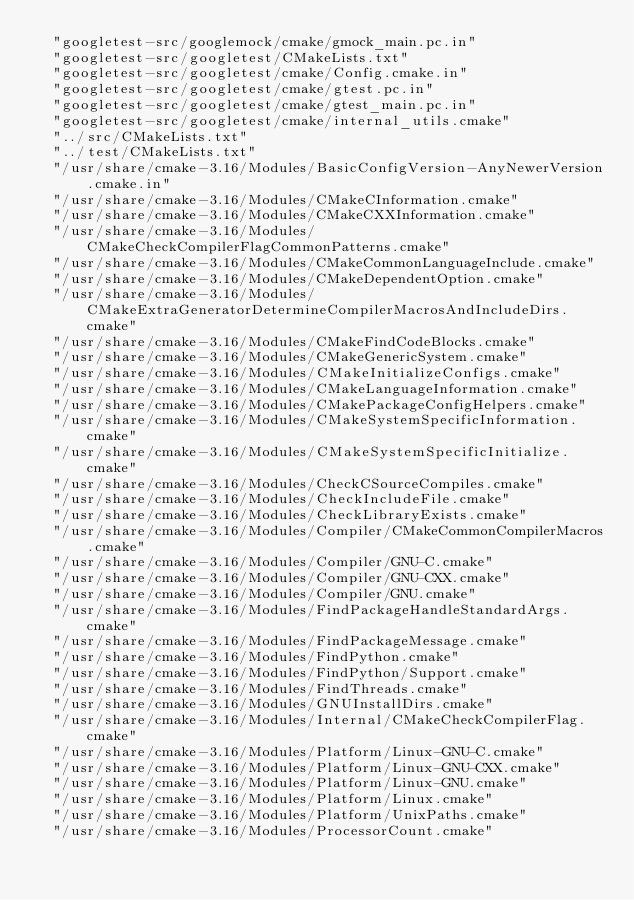Convert code to text. <code><loc_0><loc_0><loc_500><loc_500><_CMake_>  "googletest-src/googlemock/cmake/gmock_main.pc.in"
  "googletest-src/googletest/CMakeLists.txt"
  "googletest-src/googletest/cmake/Config.cmake.in"
  "googletest-src/googletest/cmake/gtest.pc.in"
  "googletest-src/googletest/cmake/gtest_main.pc.in"
  "googletest-src/googletest/cmake/internal_utils.cmake"
  "../src/CMakeLists.txt"
  "../test/CMakeLists.txt"
  "/usr/share/cmake-3.16/Modules/BasicConfigVersion-AnyNewerVersion.cmake.in"
  "/usr/share/cmake-3.16/Modules/CMakeCInformation.cmake"
  "/usr/share/cmake-3.16/Modules/CMakeCXXInformation.cmake"
  "/usr/share/cmake-3.16/Modules/CMakeCheckCompilerFlagCommonPatterns.cmake"
  "/usr/share/cmake-3.16/Modules/CMakeCommonLanguageInclude.cmake"
  "/usr/share/cmake-3.16/Modules/CMakeDependentOption.cmake"
  "/usr/share/cmake-3.16/Modules/CMakeExtraGeneratorDetermineCompilerMacrosAndIncludeDirs.cmake"
  "/usr/share/cmake-3.16/Modules/CMakeFindCodeBlocks.cmake"
  "/usr/share/cmake-3.16/Modules/CMakeGenericSystem.cmake"
  "/usr/share/cmake-3.16/Modules/CMakeInitializeConfigs.cmake"
  "/usr/share/cmake-3.16/Modules/CMakeLanguageInformation.cmake"
  "/usr/share/cmake-3.16/Modules/CMakePackageConfigHelpers.cmake"
  "/usr/share/cmake-3.16/Modules/CMakeSystemSpecificInformation.cmake"
  "/usr/share/cmake-3.16/Modules/CMakeSystemSpecificInitialize.cmake"
  "/usr/share/cmake-3.16/Modules/CheckCSourceCompiles.cmake"
  "/usr/share/cmake-3.16/Modules/CheckIncludeFile.cmake"
  "/usr/share/cmake-3.16/Modules/CheckLibraryExists.cmake"
  "/usr/share/cmake-3.16/Modules/Compiler/CMakeCommonCompilerMacros.cmake"
  "/usr/share/cmake-3.16/Modules/Compiler/GNU-C.cmake"
  "/usr/share/cmake-3.16/Modules/Compiler/GNU-CXX.cmake"
  "/usr/share/cmake-3.16/Modules/Compiler/GNU.cmake"
  "/usr/share/cmake-3.16/Modules/FindPackageHandleStandardArgs.cmake"
  "/usr/share/cmake-3.16/Modules/FindPackageMessage.cmake"
  "/usr/share/cmake-3.16/Modules/FindPython.cmake"
  "/usr/share/cmake-3.16/Modules/FindPython/Support.cmake"
  "/usr/share/cmake-3.16/Modules/FindThreads.cmake"
  "/usr/share/cmake-3.16/Modules/GNUInstallDirs.cmake"
  "/usr/share/cmake-3.16/Modules/Internal/CMakeCheckCompilerFlag.cmake"
  "/usr/share/cmake-3.16/Modules/Platform/Linux-GNU-C.cmake"
  "/usr/share/cmake-3.16/Modules/Platform/Linux-GNU-CXX.cmake"
  "/usr/share/cmake-3.16/Modules/Platform/Linux-GNU.cmake"
  "/usr/share/cmake-3.16/Modules/Platform/Linux.cmake"
  "/usr/share/cmake-3.16/Modules/Platform/UnixPaths.cmake"
  "/usr/share/cmake-3.16/Modules/ProcessorCount.cmake"</code> 